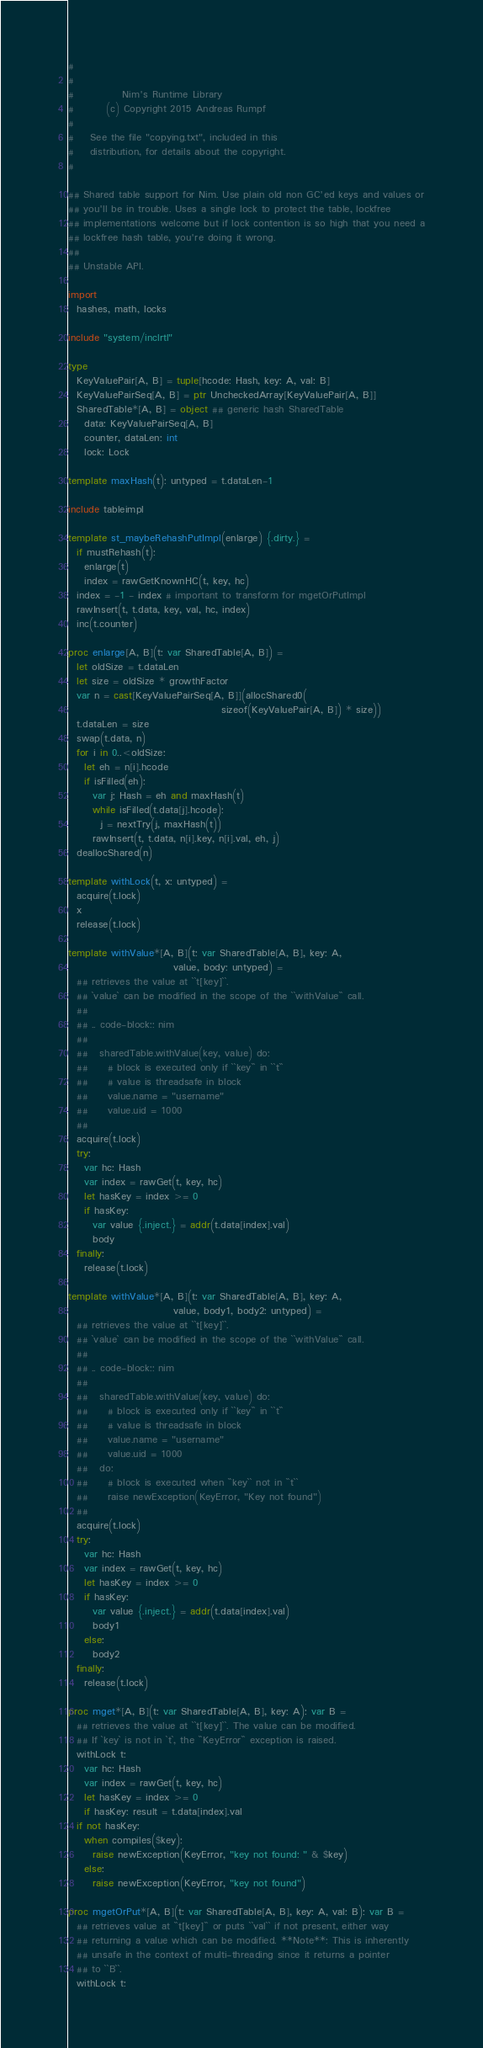Convert code to text. <code><loc_0><loc_0><loc_500><loc_500><_Nim_>#
#
#            Nim's Runtime Library
#        (c) Copyright 2015 Andreas Rumpf
#
#    See the file "copying.txt", included in this
#    distribution, for details about the copyright.
#

## Shared table support for Nim. Use plain old non GC'ed keys and values or
## you'll be in trouble. Uses a single lock to protect the table, lockfree
## implementations welcome but if lock contention is so high that you need a
## lockfree hash table, you're doing it wrong.
##
## Unstable API.

import
  hashes, math, locks

include "system/inclrtl"

type
  KeyValuePair[A, B] = tuple[hcode: Hash, key: A, val: B]
  KeyValuePairSeq[A, B] = ptr UncheckedArray[KeyValuePair[A, B]]
  SharedTable*[A, B] = object ## generic hash SharedTable
    data: KeyValuePairSeq[A, B]
    counter, dataLen: int
    lock: Lock

template maxHash(t): untyped = t.dataLen-1

include tableimpl

template st_maybeRehashPutImpl(enlarge) {.dirty.} =
  if mustRehash(t):
    enlarge(t)
    index = rawGetKnownHC(t, key, hc)
  index = -1 - index # important to transform for mgetOrPutImpl
  rawInsert(t, t.data, key, val, hc, index)
  inc(t.counter)

proc enlarge[A, B](t: var SharedTable[A, B]) =
  let oldSize = t.dataLen
  let size = oldSize * growthFactor
  var n = cast[KeyValuePairSeq[A, B]](allocShared0(
                                      sizeof(KeyValuePair[A, B]) * size))
  t.dataLen = size
  swap(t.data, n)
  for i in 0..<oldSize:
    let eh = n[i].hcode
    if isFilled(eh):
      var j: Hash = eh and maxHash(t)
      while isFilled(t.data[j].hcode):
        j = nextTry(j, maxHash(t))
      rawInsert(t, t.data, n[i].key, n[i].val, eh, j)
  deallocShared(n)

template withLock(t, x: untyped) =
  acquire(t.lock)
  x
  release(t.lock)

template withValue*[A, B](t: var SharedTable[A, B], key: A,
                          value, body: untyped) =
  ## retrieves the value at ``t[key]``.
  ## `value` can be modified in the scope of the ``withValue`` call.
  ##
  ## .. code-block:: nim
  ##
  ##   sharedTable.withValue(key, value) do:
  ##     # block is executed only if ``key`` in ``t``
  ##     # value is threadsafe in block
  ##     value.name = "username"
  ##     value.uid = 1000
  ##
  acquire(t.lock)
  try:
    var hc: Hash
    var index = rawGet(t, key, hc)
    let hasKey = index >= 0
    if hasKey:
      var value {.inject.} = addr(t.data[index].val)
      body
  finally:
    release(t.lock)

template withValue*[A, B](t: var SharedTable[A, B], key: A,
                          value, body1, body2: untyped) =
  ## retrieves the value at ``t[key]``.
  ## `value` can be modified in the scope of the ``withValue`` call.
  ##
  ## .. code-block:: nim
  ##
  ##   sharedTable.withValue(key, value) do:
  ##     # block is executed only if ``key`` in ``t``
  ##     # value is threadsafe in block
  ##     value.name = "username"
  ##     value.uid = 1000
  ##   do:
  ##     # block is executed when ``key`` not in ``t``
  ##     raise newException(KeyError, "Key not found")
  ##
  acquire(t.lock)
  try:
    var hc: Hash
    var index = rawGet(t, key, hc)
    let hasKey = index >= 0
    if hasKey:
      var value {.inject.} = addr(t.data[index].val)
      body1
    else:
      body2
  finally:
    release(t.lock)

proc mget*[A, B](t: var SharedTable[A, B], key: A): var B =
  ## retrieves the value at ``t[key]``. The value can be modified.
  ## If `key` is not in `t`, the ``KeyError`` exception is raised.
  withLock t:
    var hc: Hash
    var index = rawGet(t, key, hc)
    let hasKey = index >= 0
    if hasKey: result = t.data[index].val
  if not hasKey:
    when compiles($key):
      raise newException(KeyError, "key not found: " & $key)
    else:
      raise newException(KeyError, "key not found")

proc mgetOrPut*[A, B](t: var SharedTable[A, B], key: A, val: B): var B =
  ## retrieves value at ``t[key]`` or puts ``val`` if not present, either way
  ## returning a value which can be modified. **Note**: This is inherently
  ## unsafe in the context of multi-threading since it returns a pointer
  ## to ``B``.
  withLock t:</code> 